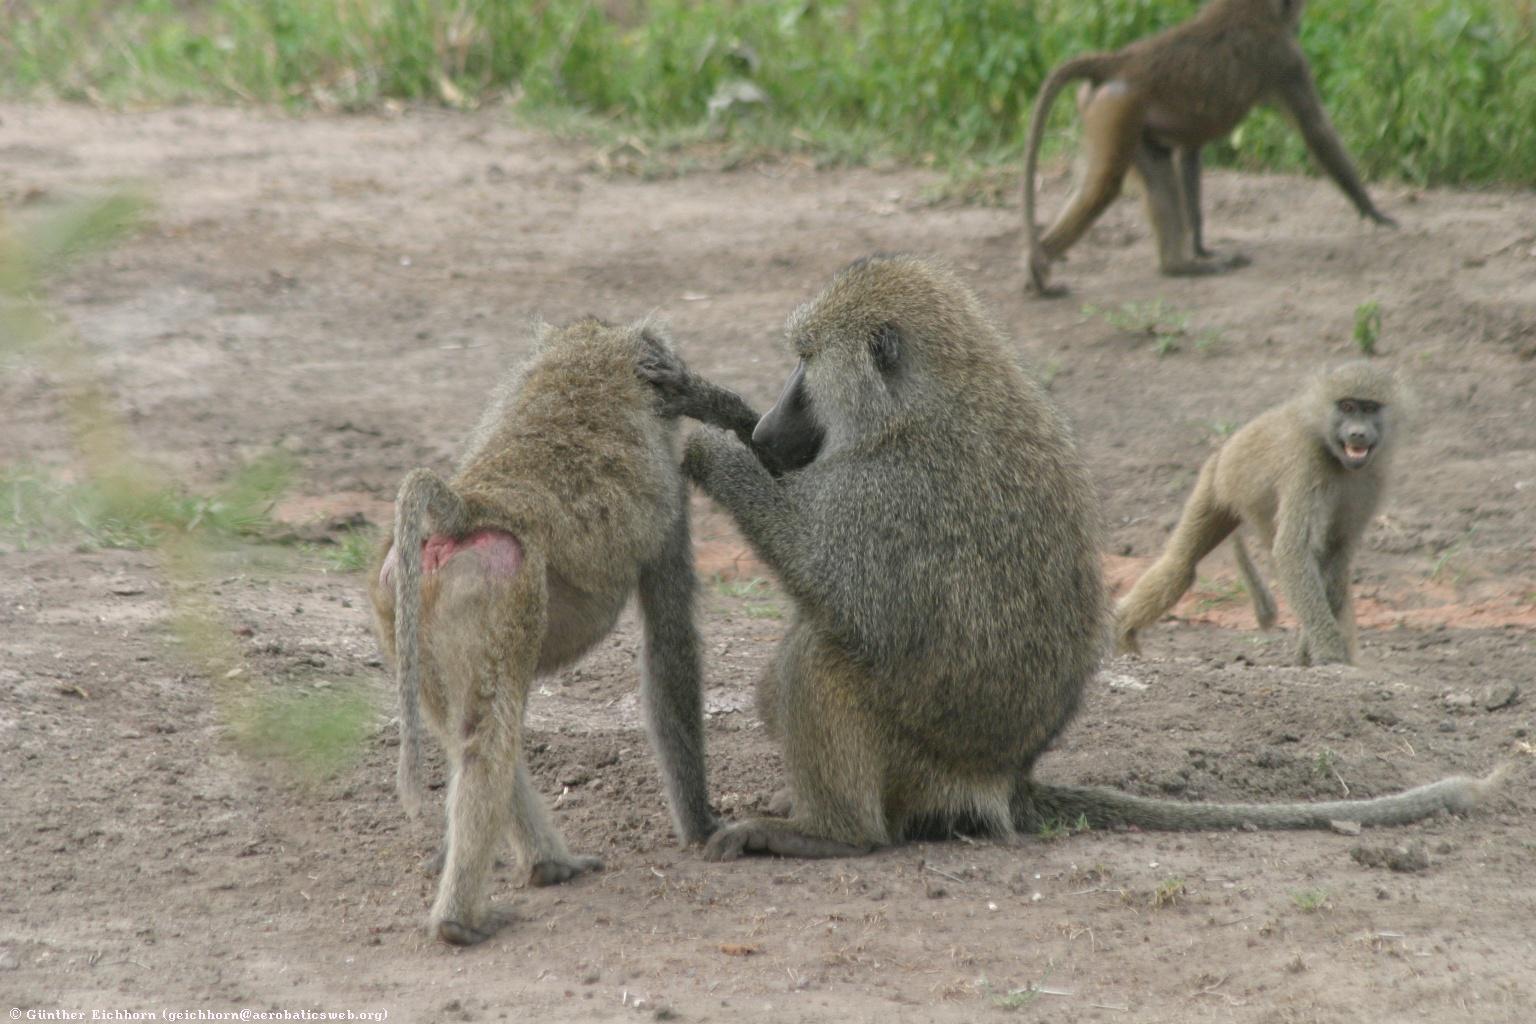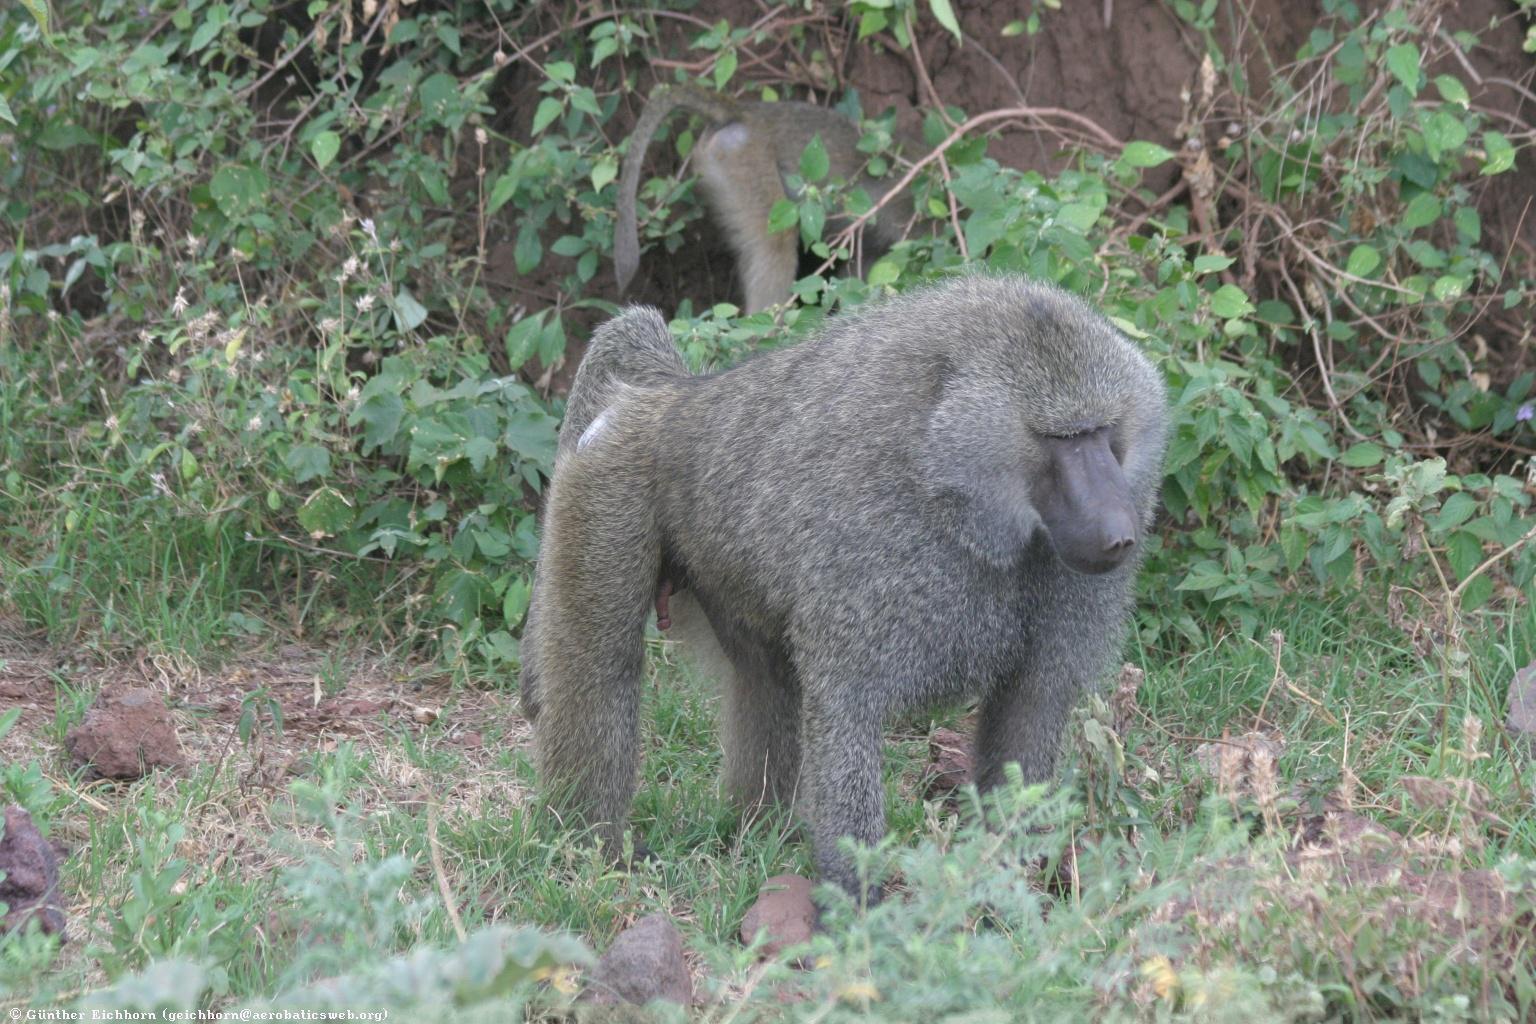The first image is the image on the left, the second image is the image on the right. Considering the images on both sides, is "No more than 2 baboons in either picture." valid? Answer yes or no. No. 